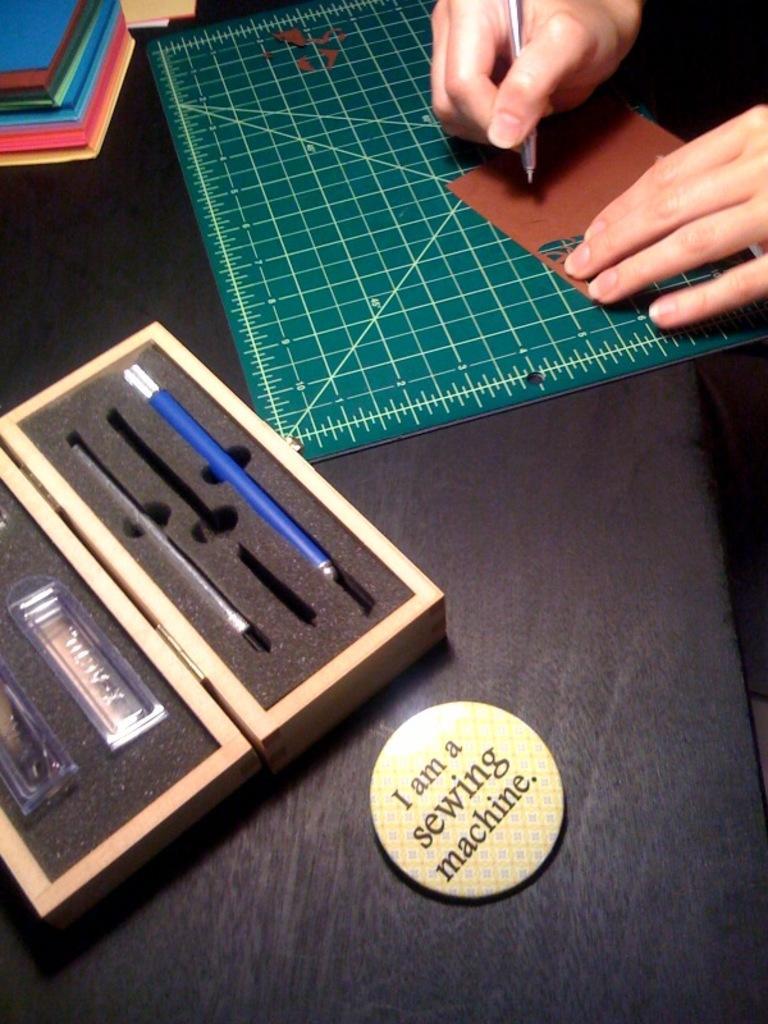In one or two sentences, can you explain what this image depicts? In the picture I can see a badge, pen box and books are kept on the table. I can see the hand of a person holding a pen on the top right side of the picture. 